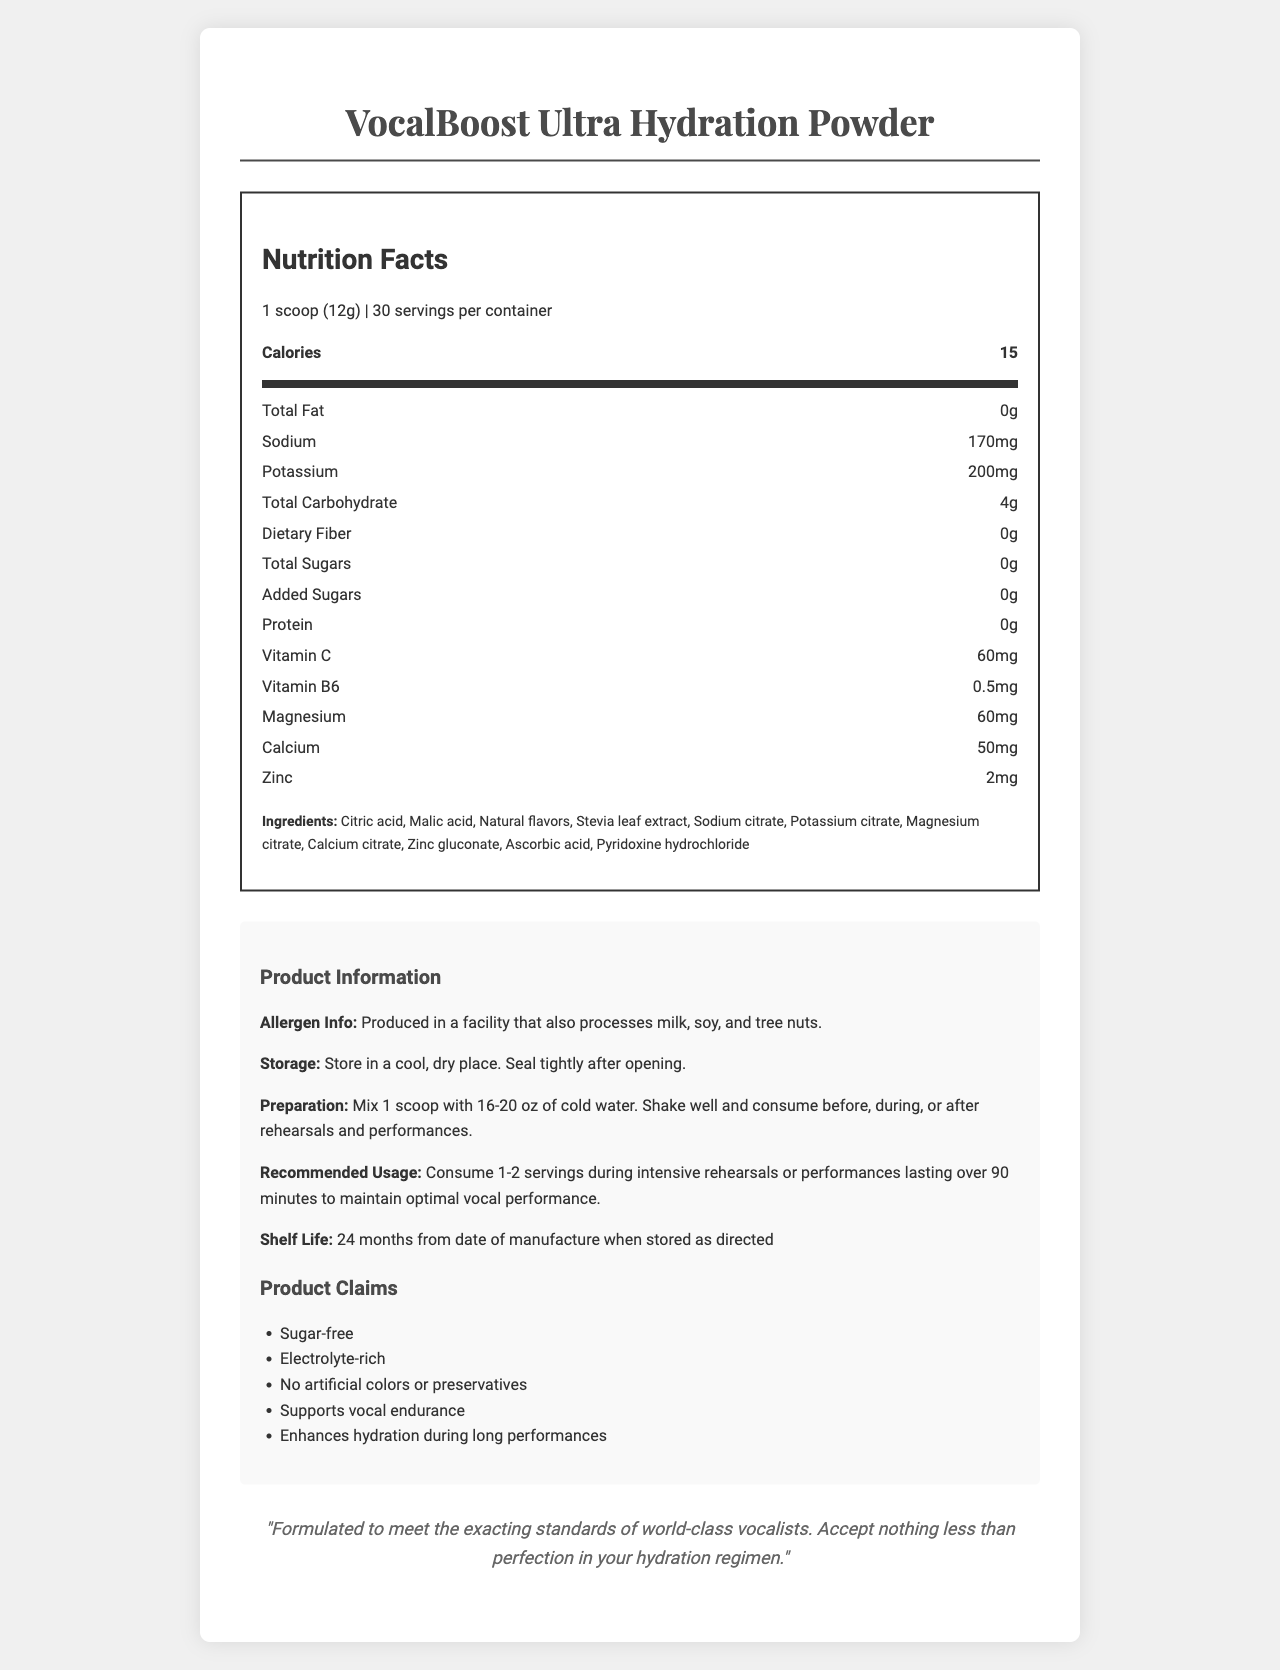what is the serving size? The serving size is listed at the beginning of the Nutrition Facts section as "1 scoop (12g)".
Answer: 1 scoop (12g) how many servings are in one container? Directly stated in the Nutrition Facts section as "30 servings per container".
Answer: 30 what are the total calories per serving? The number of calories per serving is prominently displayed as "Calories 15".
Answer: 15 list three electrolytes found in this product. Sodium (170mg), Potassium (200mg), and Magnesium (60mg) are listed in the Nutrition Facts section.
Answer: Sodium, Potassium, Magnesium does this product contain any sugars? Both Total Sugars and Added Sugars are listed as 0g in the Nutrition Facts.
Answer: No how much Vitamin C is in one serving? This information is listed under the specific nutrients in the Nutrition Facts.
Answer: 60mg how should the product be prepared? The preparation instructions are provided in the Product Information section.
Answer: Mix 1 scoop with 16-20 oz of cold water. Shake well and consume before, during, or after rehearsals and performances. what is the shelf life of this product? This information is provided under Recommended Usage in the Product Information section.
Answer: 24 months from date of manufacture when stored as directed What is the recommended usage for someone during an intensive rehearsal or performance? Clearly stated under Recommended Usage in the Product Information section.
Answer: Consume 1-2 servings during intensive rehearsals or performances lasting over 90 minutes. what are the storage instructions for this product? A. Store in the refrigerator B. Store in a cool, dry place C. Store in a damp area D. Store at room temperature The Storage Instructions in the Product Information section specify "Store in a cool, dry place."
Answer: B which of the following ingredients is not in the product? A. Citric acid B. Stevia leaf extract C. Ascorbic acid D. Aspartame Aspartame is not listed among the ingredients in the Ingredients section.
Answer: D True/False: The product is endorsed by a maestro. The Product Claims section includes a quote by a maestro endorsing the product.
Answer: True summarize the main claims and benefits of VocalBoost Ultra Hydration Powder. The document highlights the key features and claims related to the product's use and benefits, particularly for vocal performance.
Answer: VocalBoost Ultra Hydration Powder is a sugar-free, electrolyte-rich hydration solution designed to enhance hydration and support vocal endurance during long rehearsals and performances. It contains essential vitamins and minerals, including Vitamin C, Vitamin B6, Magnesium, Calcium, and Zinc, and does not include any artificial colors or preservatives. It is endorsed by a maestro to meet the standards of world-class vocalists. Why was this product formulated? The document states that it is formulated to meet vocalists' standards but does not detail the specific formulation reasons.
Answer: Not enough information 